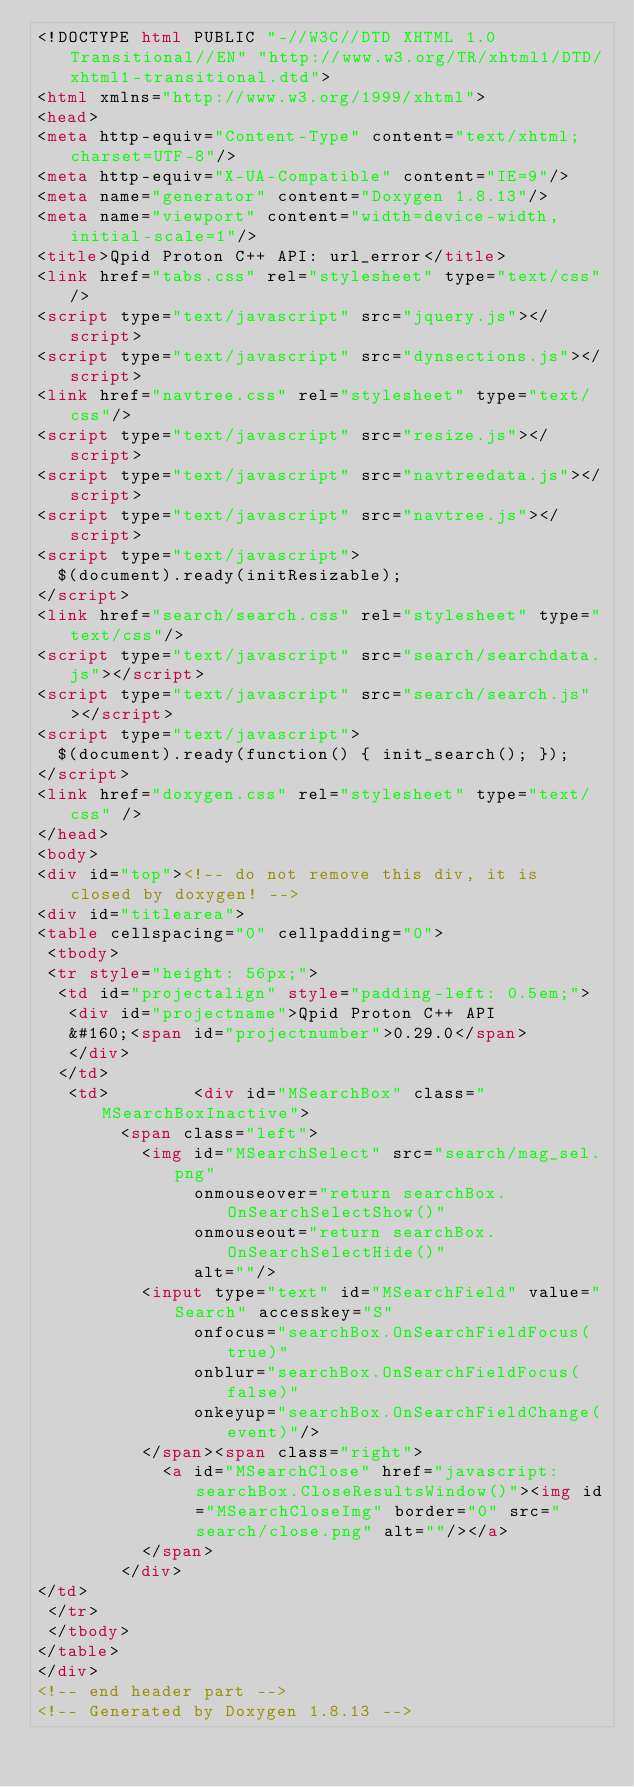<code> <loc_0><loc_0><loc_500><loc_500><_HTML_><!DOCTYPE html PUBLIC "-//W3C//DTD XHTML 1.0 Transitional//EN" "http://www.w3.org/TR/xhtml1/DTD/xhtml1-transitional.dtd">
<html xmlns="http://www.w3.org/1999/xhtml">
<head>
<meta http-equiv="Content-Type" content="text/xhtml;charset=UTF-8"/>
<meta http-equiv="X-UA-Compatible" content="IE=9"/>
<meta name="generator" content="Doxygen 1.8.13"/>
<meta name="viewport" content="width=device-width, initial-scale=1"/>
<title>Qpid Proton C++ API: url_error</title>
<link href="tabs.css" rel="stylesheet" type="text/css"/>
<script type="text/javascript" src="jquery.js"></script>
<script type="text/javascript" src="dynsections.js"></script>
<link href="navtree.css" rel="stylesheet" type="text/css"/>
<script type="text/javascript" src="resize.js"></script>
<script type="text/javascript" src="navtreedata.js"></script>
<script type="text/javascript" src="navtree.js"></script>
<script type="text/javascript">
  $(document).ready(initResizable);
</script>
<link href="search/search.css" rel="stylesheet" type="text/css"/>
<script type="text/javascript" src="search/searchdata.js"></script>
<script type="text/javascript" src="search/search.js"></script>
<script type="text/javascript">
  $(document).ready(function() { init_search(); });
</script>
<link href="doxygen.css" rel="stylesheet" type="text/css" />
</head>
<body>
<div id="top"><!-- do not remove this div, it is closed by doxygen! -->
<div id="titlearea">
<table cellspacing="0" cellpadding="0">
 <tbody>
 <tr style="height: 56px;">
  <td id="projectalign" style="padding-left: 0.5em;">
   <div id="projectname">Qpid Proton C++ API
   &#160;<span id="projectnumber">0.29.0</span>
   </div>
  </td>
   <td>        <div id="MSearchBox" class="MSearchBoxInactive">
        <span class="left">
          <img id="MSearchSelect" src="search/mag_sel.png"
               onmouseover="return searchBox.OnSearchSelectShow()"
               onmouseout="return searchBox.OnSearchSelectHide()"
               alt=""/>
          <input type="text" id="MSearchField" value="Search" accesskey="S"
               onfocus="searchBox.OnSearchFieldFocus(true)" 
               onblur="searchBox.OnSearchFieldFocus(false)" 
               onkeyup="searchBox.OnSearchFieldChange(event)"/>
          </span><span class="right">
            <a id="MSearchClose" href="javascript:searchBox.CloseResultsWindow()"><img id="MSearchCloseImg" border="0" src="search/close.png" alt=""/></a>
          </span>
        </div>
</td>
 </tr>
 </tbody>
</table>
</div>
<!-- end header part -->
<!-- Generated by Doxygen 1.8.13 --></code> 